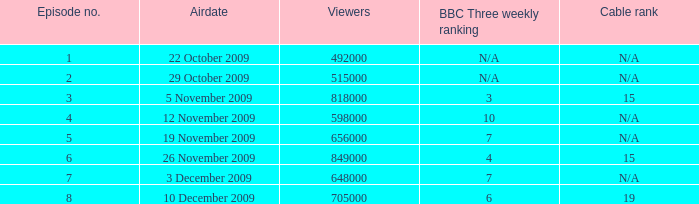What is the  cable rank for episode no. 4? N/A. 